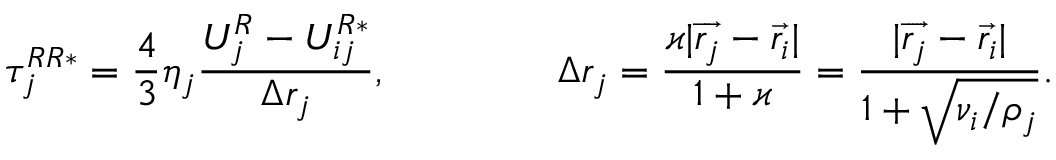<formula> <loc_0><loc_0><loc_500><loc_500>\tau _ { j } ^ { R R * } = \frac { 4 } { 3 } \eta _ { j } \frac { U _ { j } ^ { R } - U _ { i j } ^ { R * } } { \Delta r _ { j } } , \quad \Delta r _ { j } = \frac { \varkappa | \overrightarrow { r _ { j } } - \overrightarrow { r _ { i } } | } { 1 + \varkappa } = \frac { | \overrightarrow { r _ { j } } - \overrightarrow { r _ { i } } | } { 1 + \sqrt { \nu _ { i } / \rho _ { j } } } .</formula> 